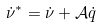Convert formula to latex. <formula><loc_0><loc_0><loc_500><loc_500>\dot { \nu } ^ { \ast } = \dot { \nu } + \mathcal { A } \dot { q }</formula> 